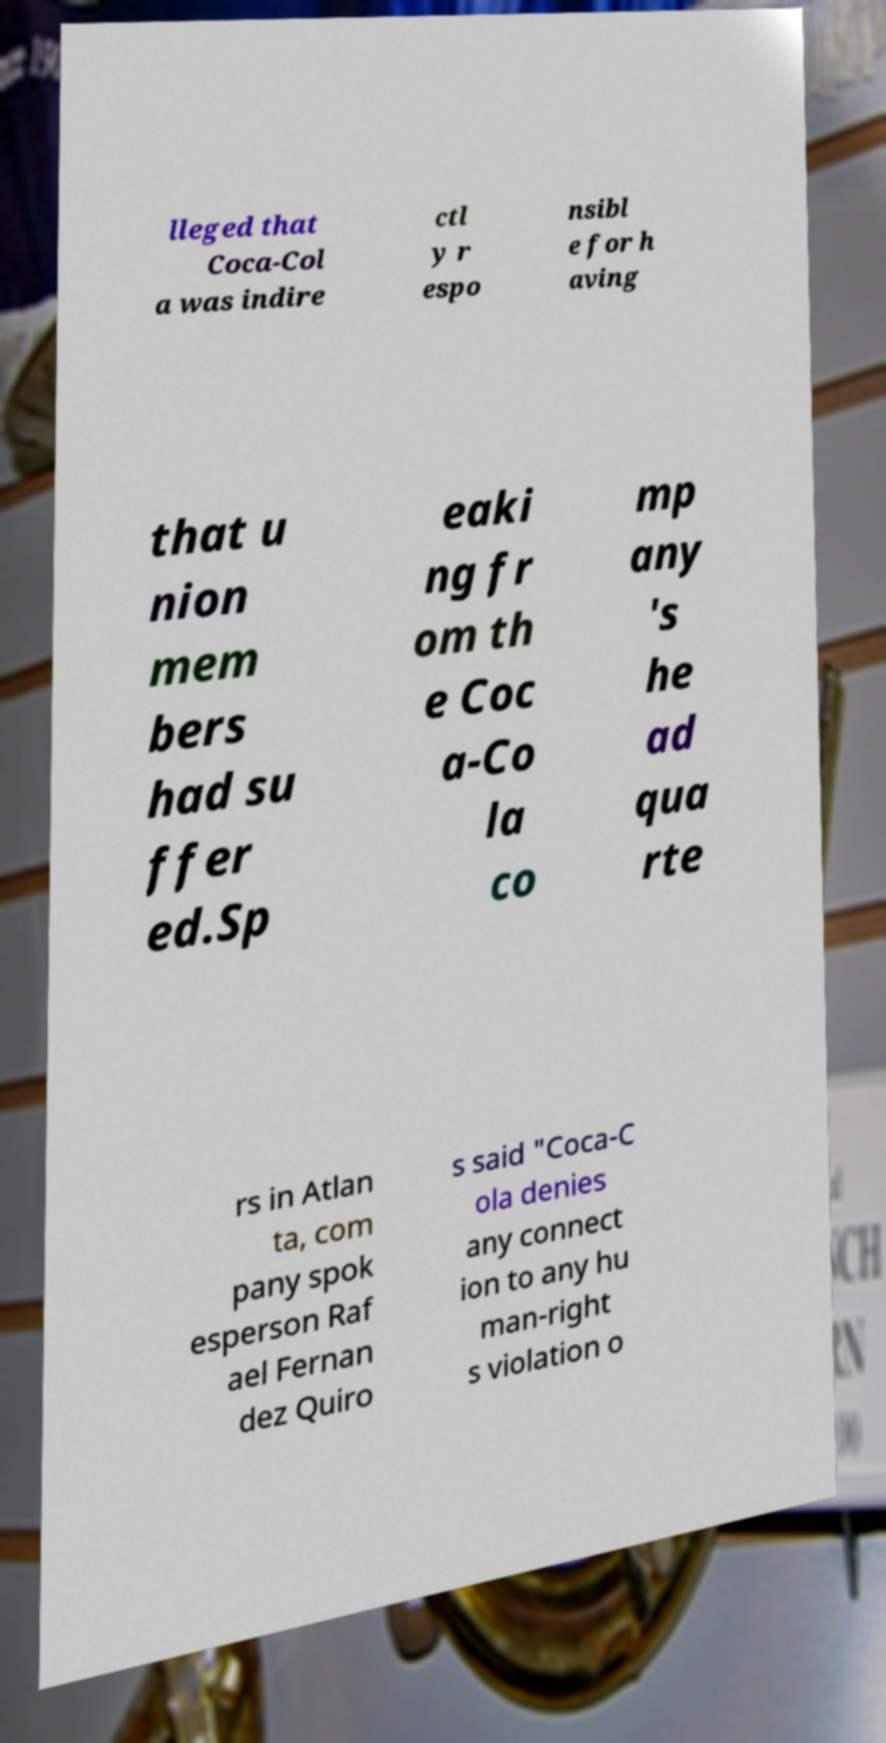I need the written content from this picture converted into text. Can you do that? lleged that Coca-Col a was indire ctl y r espo nsibl e for h aving that u nion mem bers had su ffer ed.Sp eaki ng fr om th e Coc a-Co la co mp any 's he ad qua rte rs in Atlan ta, com pany spok esperson Raf ael Fernan dez Quiro s said "Coca-C ola denies any connect ion to any hu man-right s violation o 